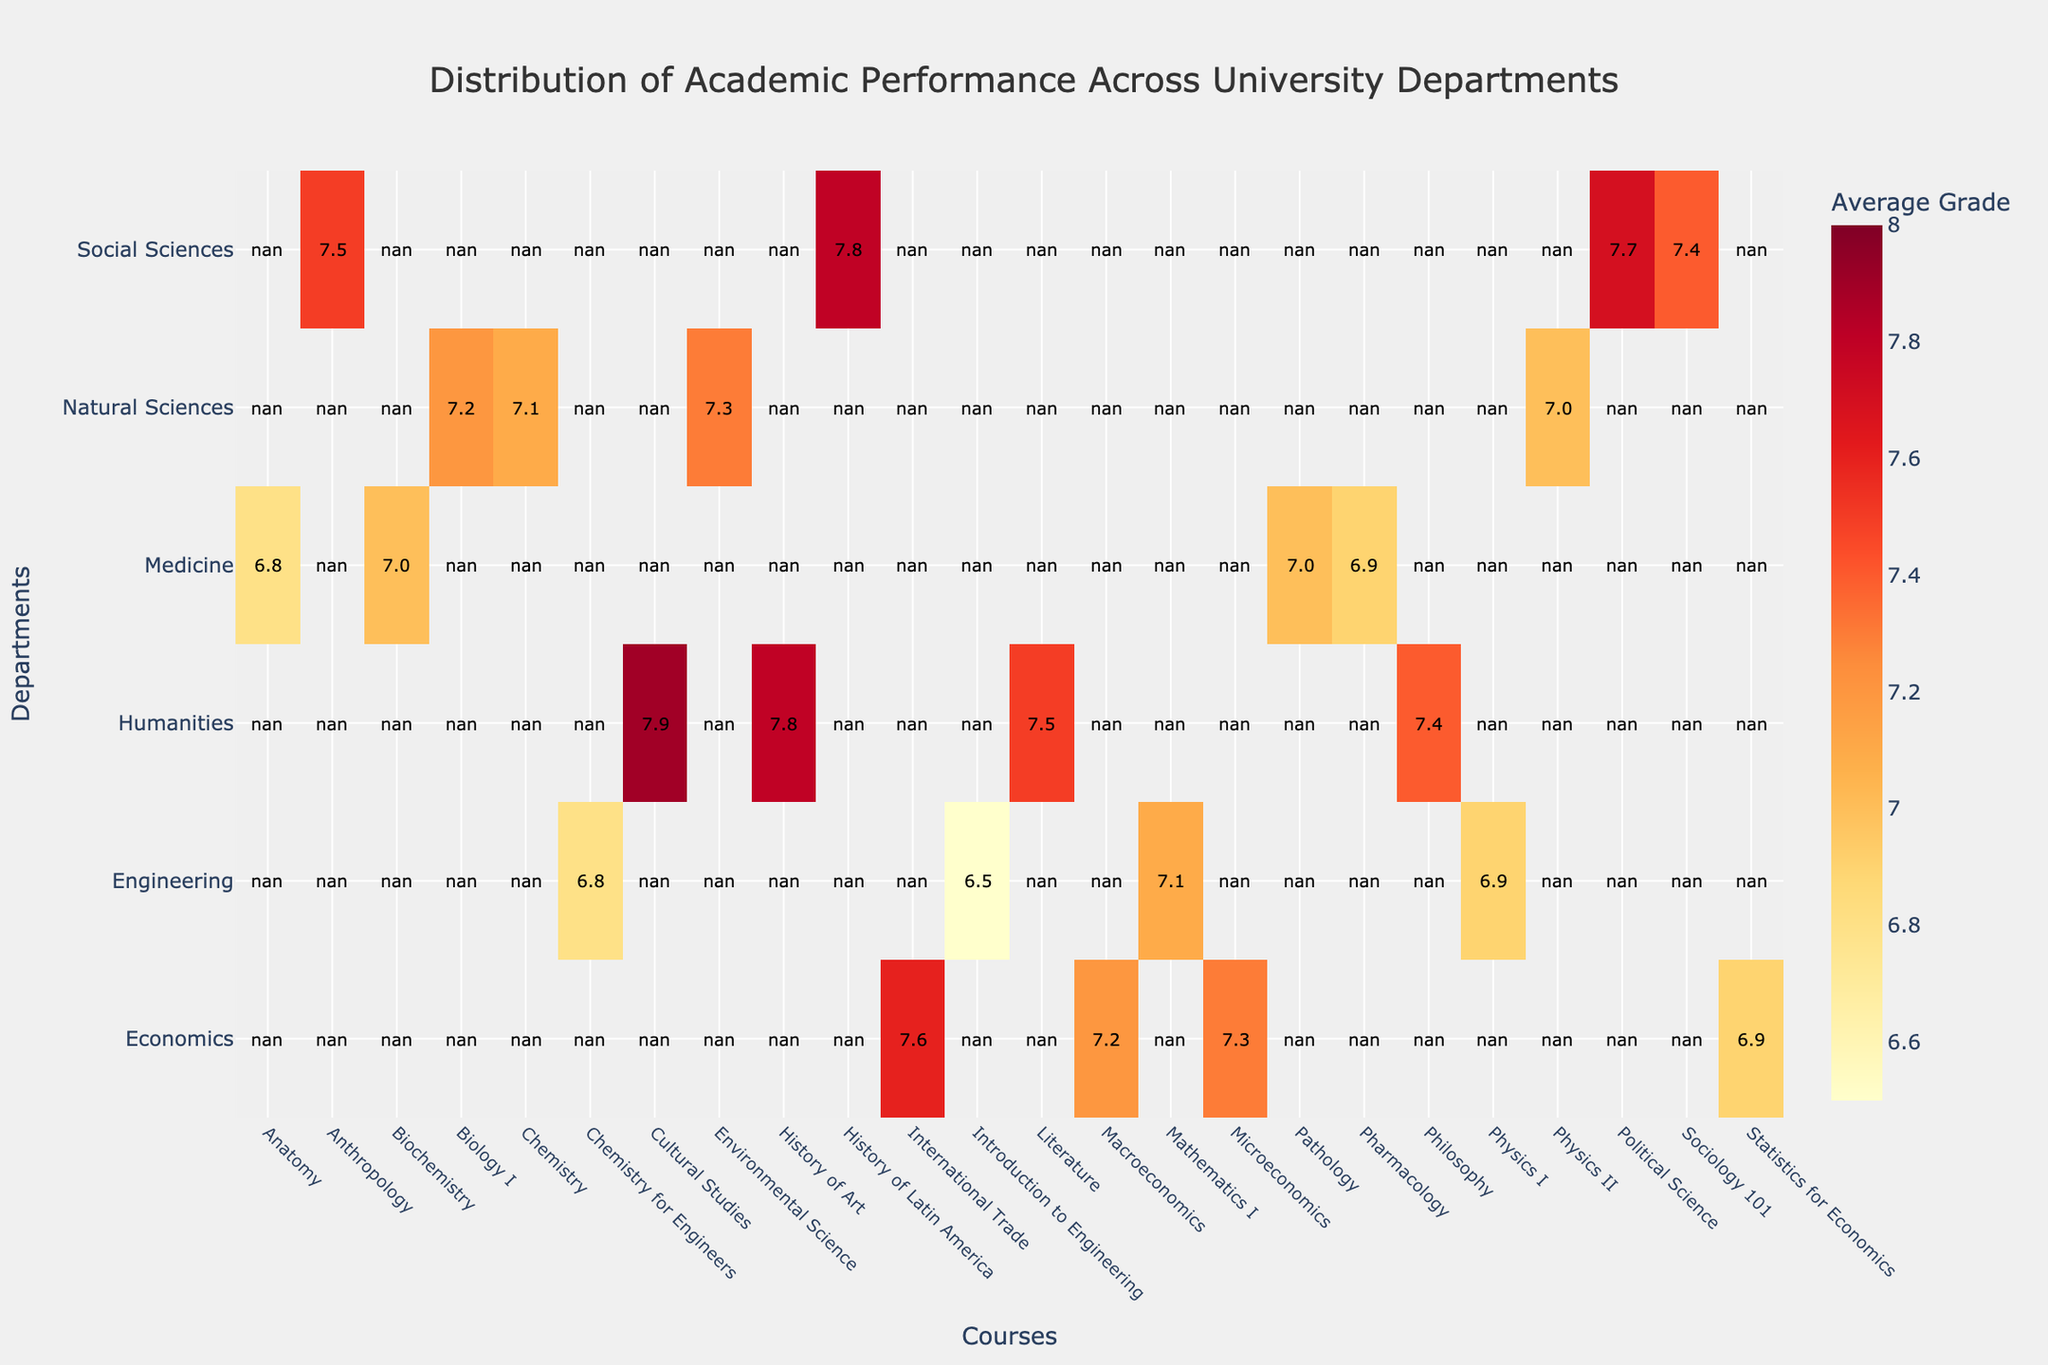What's the average grade for the 'Physics I' course in Engineering? Find the cell corresponding to Engineering and 'Physics I'. The value in this cell is the average grade for that course. In this case, it is 6.9.
Answer: 6.9 Which department has the highest average grade? Identify the department with the highest individual average grades within their courses. Cultural Studies within Humanities has the highest average grade of 7.9.
Answer: Humanities What's the range of average grades in the Natural Sciences department? Find the highest and lowest average grades within the Natural Sciences. The highest is 7.3 (Environmental Science) and the lowest is 7.0 (Physics II). The range is calculated as 7.3 - 7.0.
Answer: 0.3 How many courses in Social Sciences have an average grade above 7.5? Look at the Social Sciences department and count the number of courses with grades greater than 7.5. These are Political Science (7.7) and History of Latin America (7.8), so there are 2 courses.
Answer: 2 Compare the performance in 'Mathematics I' in Engineering with 'Statistics for Economics' in Economics. Which has a higher average grade? Check the average grades for 'Mathematics I' in Engineering (7.1) and 'Statistics for Economics' in Economics (6.9). 'Mathematics I' has a higher grade.
Answer: Mathematics I Which courses in Medicine have an average grade equal to the overall highest average grade? Find the overall highest average grade in the heatmap, which is 7.9. No courses in Medicine have this exact grade.
Answer: None What is the average grade for all courses in the Economics department? Add the average grades of all courses in Economics and divide by the number of courses: (7.3 + 7.2 + 6.9 + 7.6) / 4 = 7.25.
Answer: 7.25 Which has a lower average grade: 'Anatomy' in Medicine or 'Introduction to Engineering' in Engineering? Compare the average grades for 'Anatomy' (6.8) and 'Introduction to Engineering' (6.5). 'Introduction to Engineering' has a lower grade.
Answer: Introduction to Engineering What is the overall highest average grade present in the heatmap? Scan through the heatmap to identify the course with the highest grade. Cultural Studies in Humanities has a grade of 7.9, which is the highest.
Answer: 7.9 How does 'Biochemistry' in Medicine compare to 'Philosophy' in Humanities in terms of average grade? Check the average grades for 'Biochemistry' in Medicine (7.0) and 'Philosophy' in Humanities (7.4). 'Philosophy' has a higher average grade.
Answer: Philosophy 